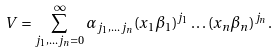Convert formula to latex. <formula><loc_0><loc_0><loc_500><loc_500>V = \sum _ { j _ { 1 } , \dots j _ { n } = 0 } ^ { \infty } \alpha _ { j _ { 1 } , \dots j _ { n } } ( x _ { 1 } \beta _ { 1 } ) ^ { j _ { 1 } } \dots ( x _ { n } \beta _ { n } ) ^ { j _ { n } } .</formula> 